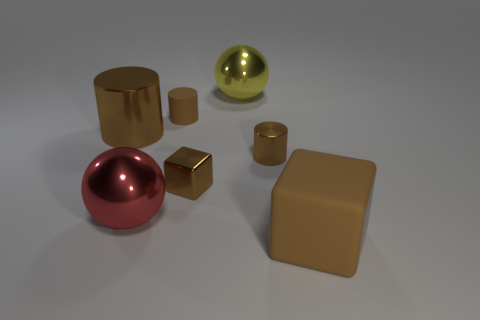The big object that is to the left of the large cube and in front of the big brown shiny thing is made of what material?
Your response must be concise. Metal. Is the shape of the rubber object that is right of the big yellow shiny thing the same as  the large red thing?
Ensure brevity in your answer.  No. What is the shape of the rubber thing in front of the small rubber cylinder?
Offer a very short reply. Cube. There is a big rubber object; does it have the same shape as the shiny object that is left of the large red thing?
Keep it short and to the point. No. Do the large yellow thing and the red shiny object have the same shape?
Your answer should be very brief. Yes. How many things are yellow objects or rubber things that are on the left side of the yellow metal ball?
Make the answer very short. 2. What is the material of the large block that is the same color as the large metal cylinder?
Your answer should be very brief. Rubber. Does the shiny object that is behind the rubber cylinder have the same size as the tiny brown shiny cylinder?
Provide a short and direct response. No. What number of tiny matte cylinders are in front of the cylinder that is behind the large brown thing on the left side of the small brown metal cylinder?
Offer a very short reply. 0. How many blue things are either large matte blocks or large cylinders?
Your answer should be very brief. 0. 